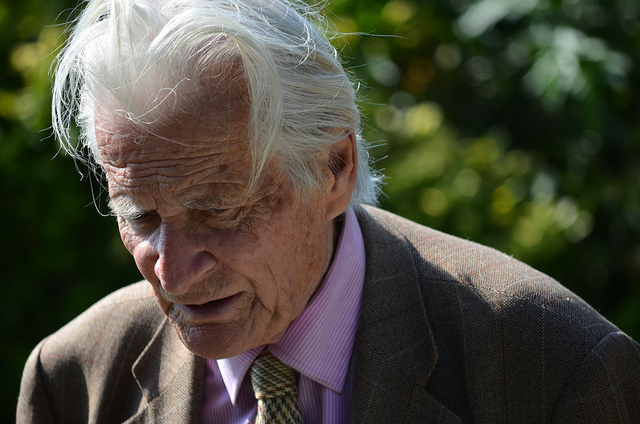<image>How is this man's posture? It is unknown how the man's posture is. It can be seen as either bowed, slumped, stopped, poor, mediocre, slouched, or hunched. How is this man's posture? The posture of this man is unclear. 